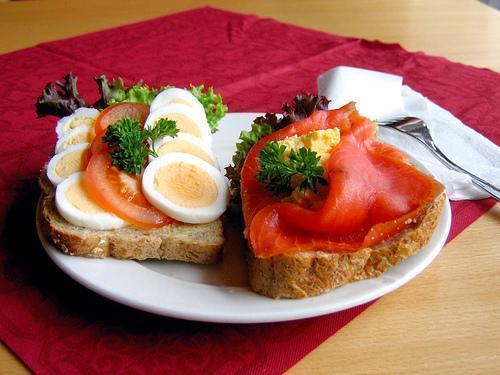Which food came from an unborn animal?
From the following set of four choices, select the accurate answer to respond to the question.
Options: Meat, vegetables, eggs, bread. Eggs. 